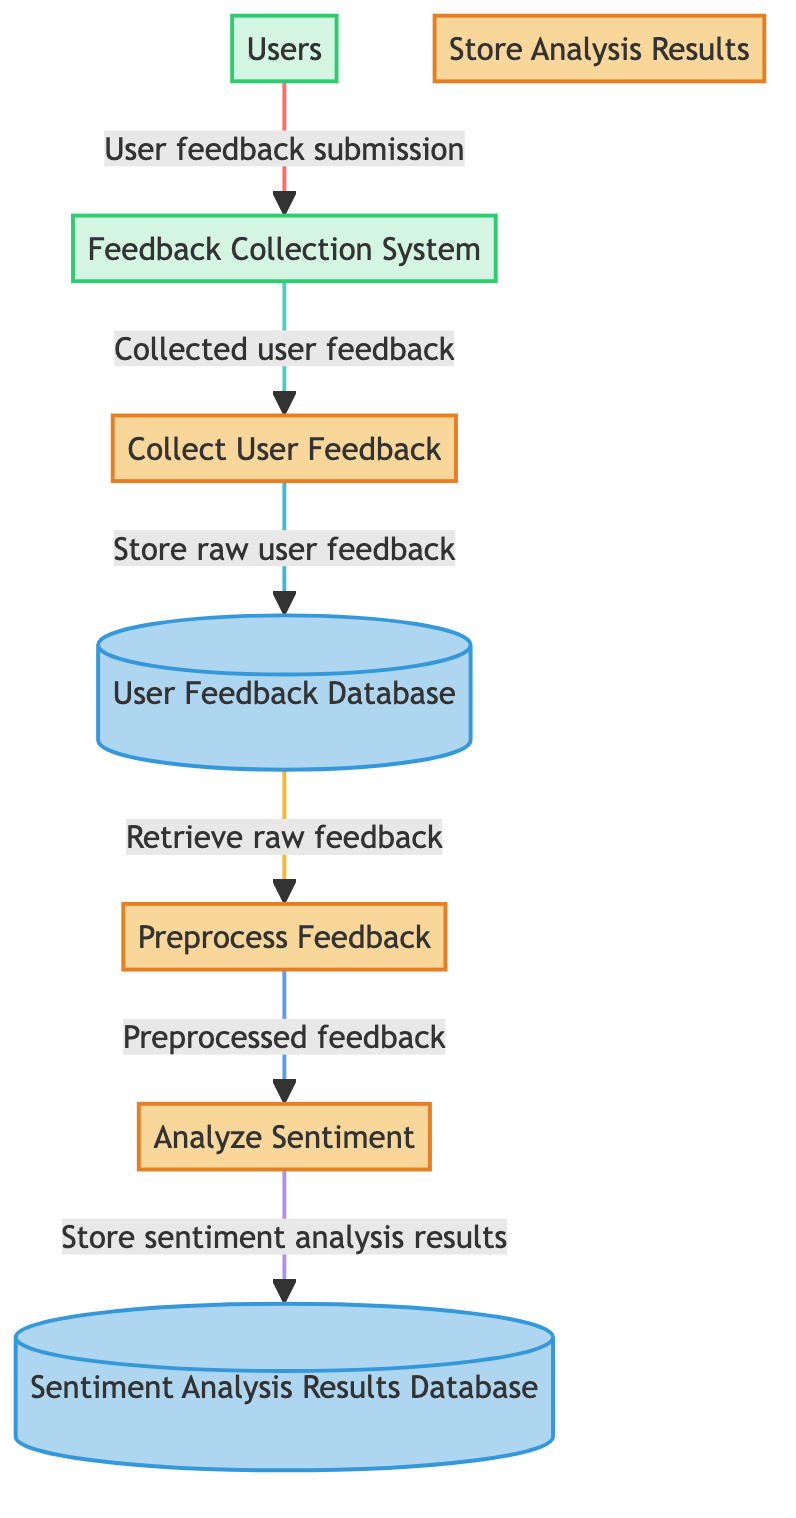What is the first process in the diagram? The first process in the diagram is "Collect User Feedback." It is the first node in the flow of activities, indicating the starting point for gathering user feedback.
Answer: Collect User Feedback How many data stores are present in the diagram? There are two data stores in the diagram: "User Feedback Database" and "Sentiment Analysis Results Database." Counting them gives a total of two data stores.
Answer: 2 Which external entity provides feedback? The external entity that provides feedback is "Users." This entity is specifically mentioned in the diagram as the source of feedback for the system.
Answer: Users What process follows the "Preprocess Feedback"? The process that follows "Preprocess Feedback" is "Analyze Sentiment." This can be traced by following the flow from the preprocessing step to the analysis step in the diagram.
Answer: Analyze Sentiment Where does the "Store sentiment analysis results" process send data? The "Store sentiment analysis results" process sends data to the "Sentiment Analysis Results Database." This is shown in the diagram as the end point for the results obtained from the sentiment analysis process.
Answer: Sentiment Analysis Results Database Which data store retrieves raw feedback for preprocessing? The data store that retrieves raw feedback for preprocessing is the "User Feedback Database." This is indicated by the flow from the data store to the preprocessing process.
Answer: User Feedback Database What type of systems does "Feedback Collection System" refer to? The "Feedback Collection System" refers to systems used to collect feedback from users, such as web forms and mobile apps. These are specifically designed to gather user input.
Answer: web forms, mobile apps How many processes are in the diagram? There are four processes in the diagram: "Collect User Feedback," "Preprocess Feedback," "Analyze Sentiment," and "Store Analysis Results." Counting these processes yields a total of four.
Answer: 4 What is the last step in the data flow? The last step in the data flow is "Store Analysis Results." This process concludes the sequence of operations presented in the diagram.
Answer: Store Analysis Results 